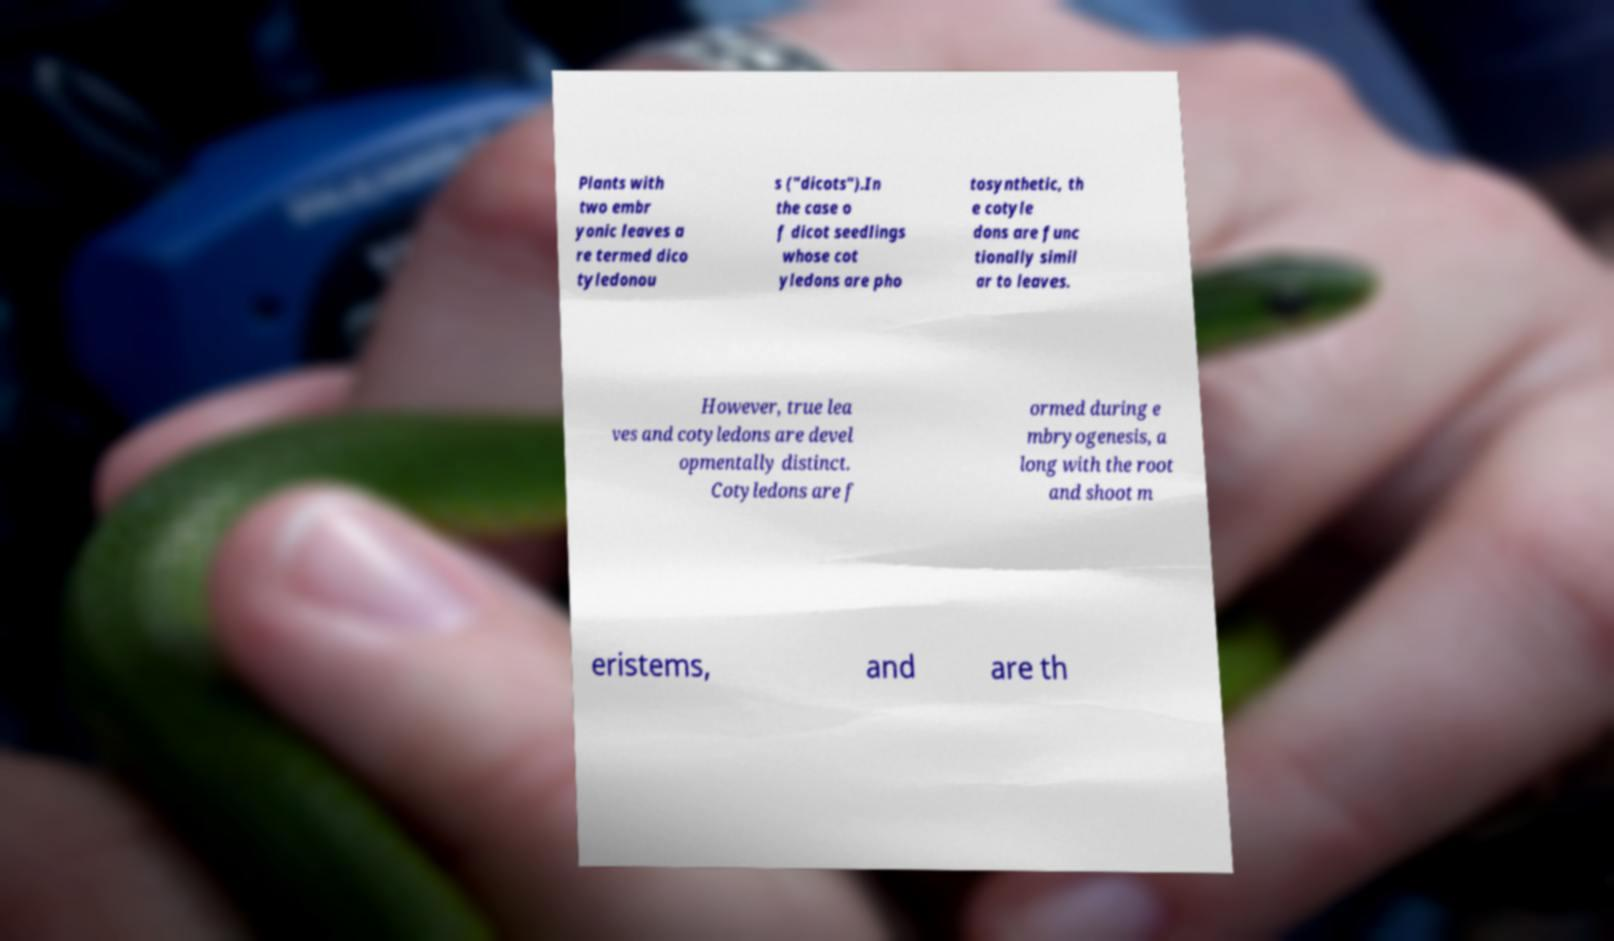Can you accurately transcribe the text from the provided image for me? Plants with two embr yonic leaves a re termed dico tyledonou s ("dicots").In the case o f dicot seedlings whose cot yledons are pho tosynthetic, th e cotyle dons are func tionally simil ar to leaves. However, true lea ves and cotyledons are devel opmentally distinct. Cotyledons are f ormed during e mbryogenesis, a long with the root and shoot m eristems, and are th 